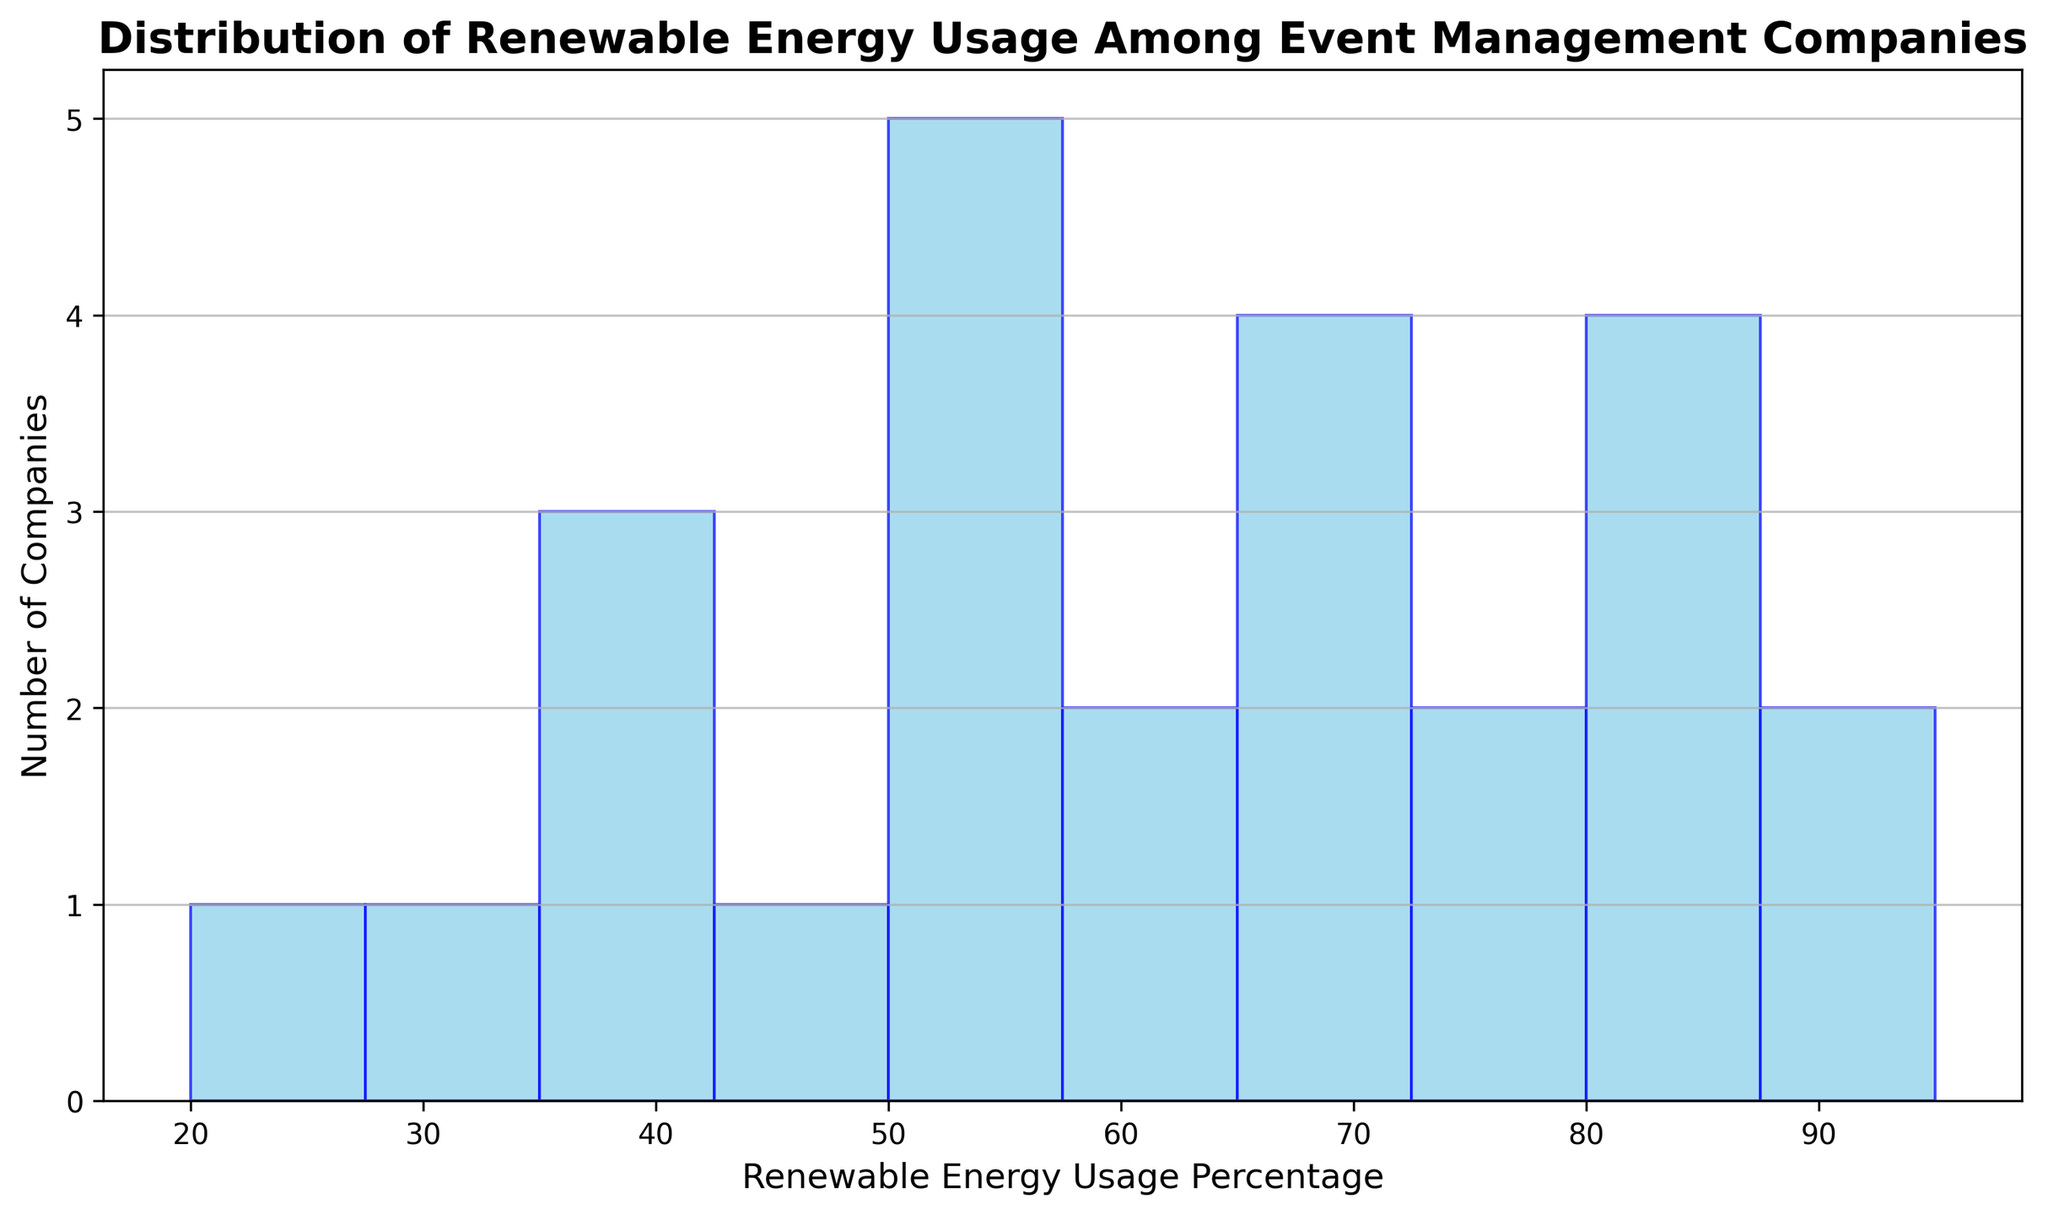What's the most common range of renewable energy usage among event management companies? Look for the tallest bar in the histogram. The tallest bar represents the range with the highest frequency of companies.
Answer: 50-60% How many companies use at least 75% renewable energy? Identify the bars in the histogram that represent 75% and higher. Count the number of companies in these bars by summing the frequencies.
Answer: 6 What percentage range has the least number of companies? Identify the shortest bar in the histogram. The shortest bar represents the range with the fewest companies.
Answer: 10-20% What is the median range of renewable energy usage? To find the median, locate the middle value in the ordered list of percentages. The histogram bins show that most companies fall in the range of 50-60% and 60-70%, so the median falls within these values.
Answer: 50-60% Which renewable energy usage range encompasses the second highest number of companies? Identify the second tallest bar in the histogram. The tallest bar represents 50-60%, and the second tallest bar represents 60-70%.
Answer: 60-70% Approximately how many companies have renewable energy usage below 50%? Identify the bars that represent usage below 50%. Sum the frequencies of these bars to get the total number of companies.
Answer: 6 Is the number of companies using 80-90% renewable energy greater than those using 20-30%? Compare the heights of the bars representing 80-90% and 20-30%. The frequency is higher for the 80-90% range.
Answer: Yes What’s the average range of renewable energy usage among companies? To find the average, calculate the midpoint of each range and multiply by the number of companies in that range. Summarize the total and divide by the number of companies (25 in this case). Average calculation lies roughly between 50%-60%.
Answer: 50-60% How many companies fall into the 40-50% range? Identify the bar representing the 40-50% range and note its frequency.
Answer: 2 Are there more companies using 70-80% renewable energy or 80-90%? Compare the heights of the bars representing 70-80% and 80-90%. The frequency is higher for the 70-80% range.
Answer: 70-80% 